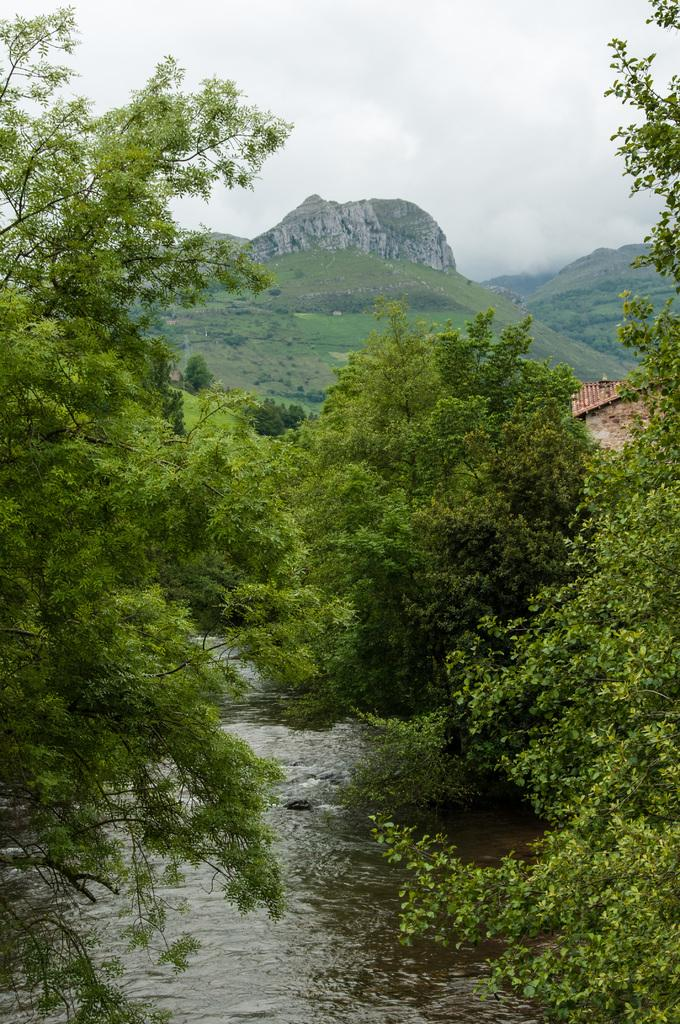What is the primary element visible in the image? There is water in the image. What can be seen in the background of the image? There are trees, grass, and mountains in the background of the image. What is the color of the trees and grass in the image? The trees and grass are green in the image. What is the color of the sky in the image? The sky is white in color. What type of bread can be seen floating on the water in the image? There is no bread present in the image; it only features water, trees, grass, mountains, and a white sky. 